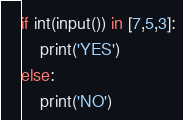<code> <loc_0><loc_0><loc_500><loc_500><_Python_>if int(input()) in [7,5,3]:
    print('YES')
else:
    print('NO')</code> 